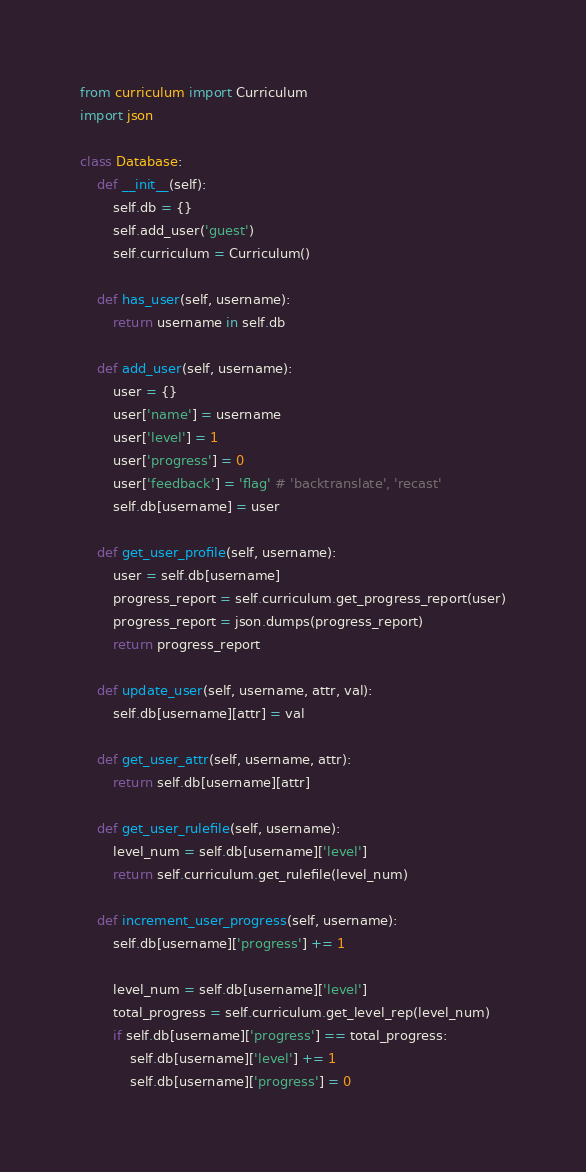Convert code to text. <code><loc_0><loc_0><loc_500><loc_500><_Python_>from curriculum import Curriculum
import json

class Database:
    def __init__(self):
        self.db = {}
        self.add_user('guest')
        self.curriculum = Curriculum()

    def has_user(self, username):
        return username in self.db

    def add_user(self, username):
        user = {}
        user['name'] = username
        user['level'] = 1
        user['progress'] = 0
        user['feedback'] = 'flag' # 'backtranslate', 'recast'
        self.db[username] = user

    def get_user_profile(self, username):
        user = self.db[username]
        progress_report = self.curriculum.get_progress_report(user)
        progress_report = json.dumps(progress_report)
        return progress_report

    def update_user(self, username, attr, val):
        self.db[username][attr] = val

    def get_user_attr(self, username, attr):
        return self.db[username][attr]

    def get_user_rulefile(self, username):
        level_num = self.db[username]['level']
        return self.curriculum.get_rulefile(level_num)

    def increment_user_progress(self, username):
        self.db[username]['progress'] += 1

        level_num = self.db[username]['level']
        total_progress = self.curriculum.get_level_rep(level_num)
        if self.db[username]['progress'] == total_progress:
            self.db[username]['level'] += 1
            self.db[username]['progress'] = 0
</code> 